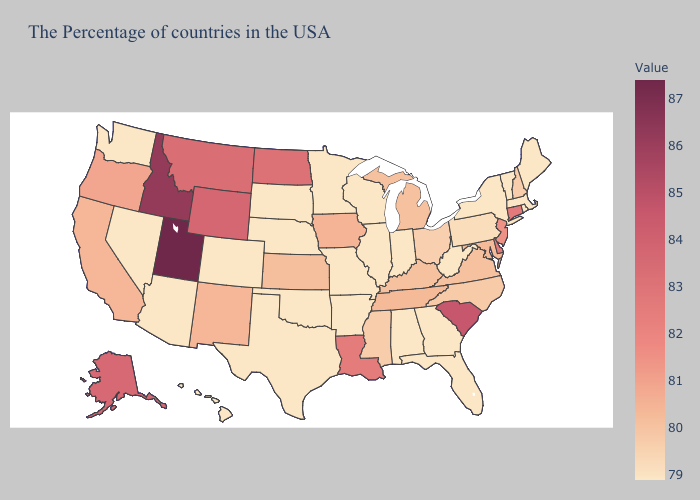Is the legend a continuous bar?
Short answer required. Yes. Does New York have the highest value in the Northeast?
Give a very brief answer. No. Does Utah have the highest value in the USA?
Write a very short answer. Yes. Which states have the highest value in the USA?
Write a very short answer. Utah. Does Louisiana have the lowest value in the USA?
Short answer required. No. Does Utah have the highest value in the West?
Answer briefly. Yes. 